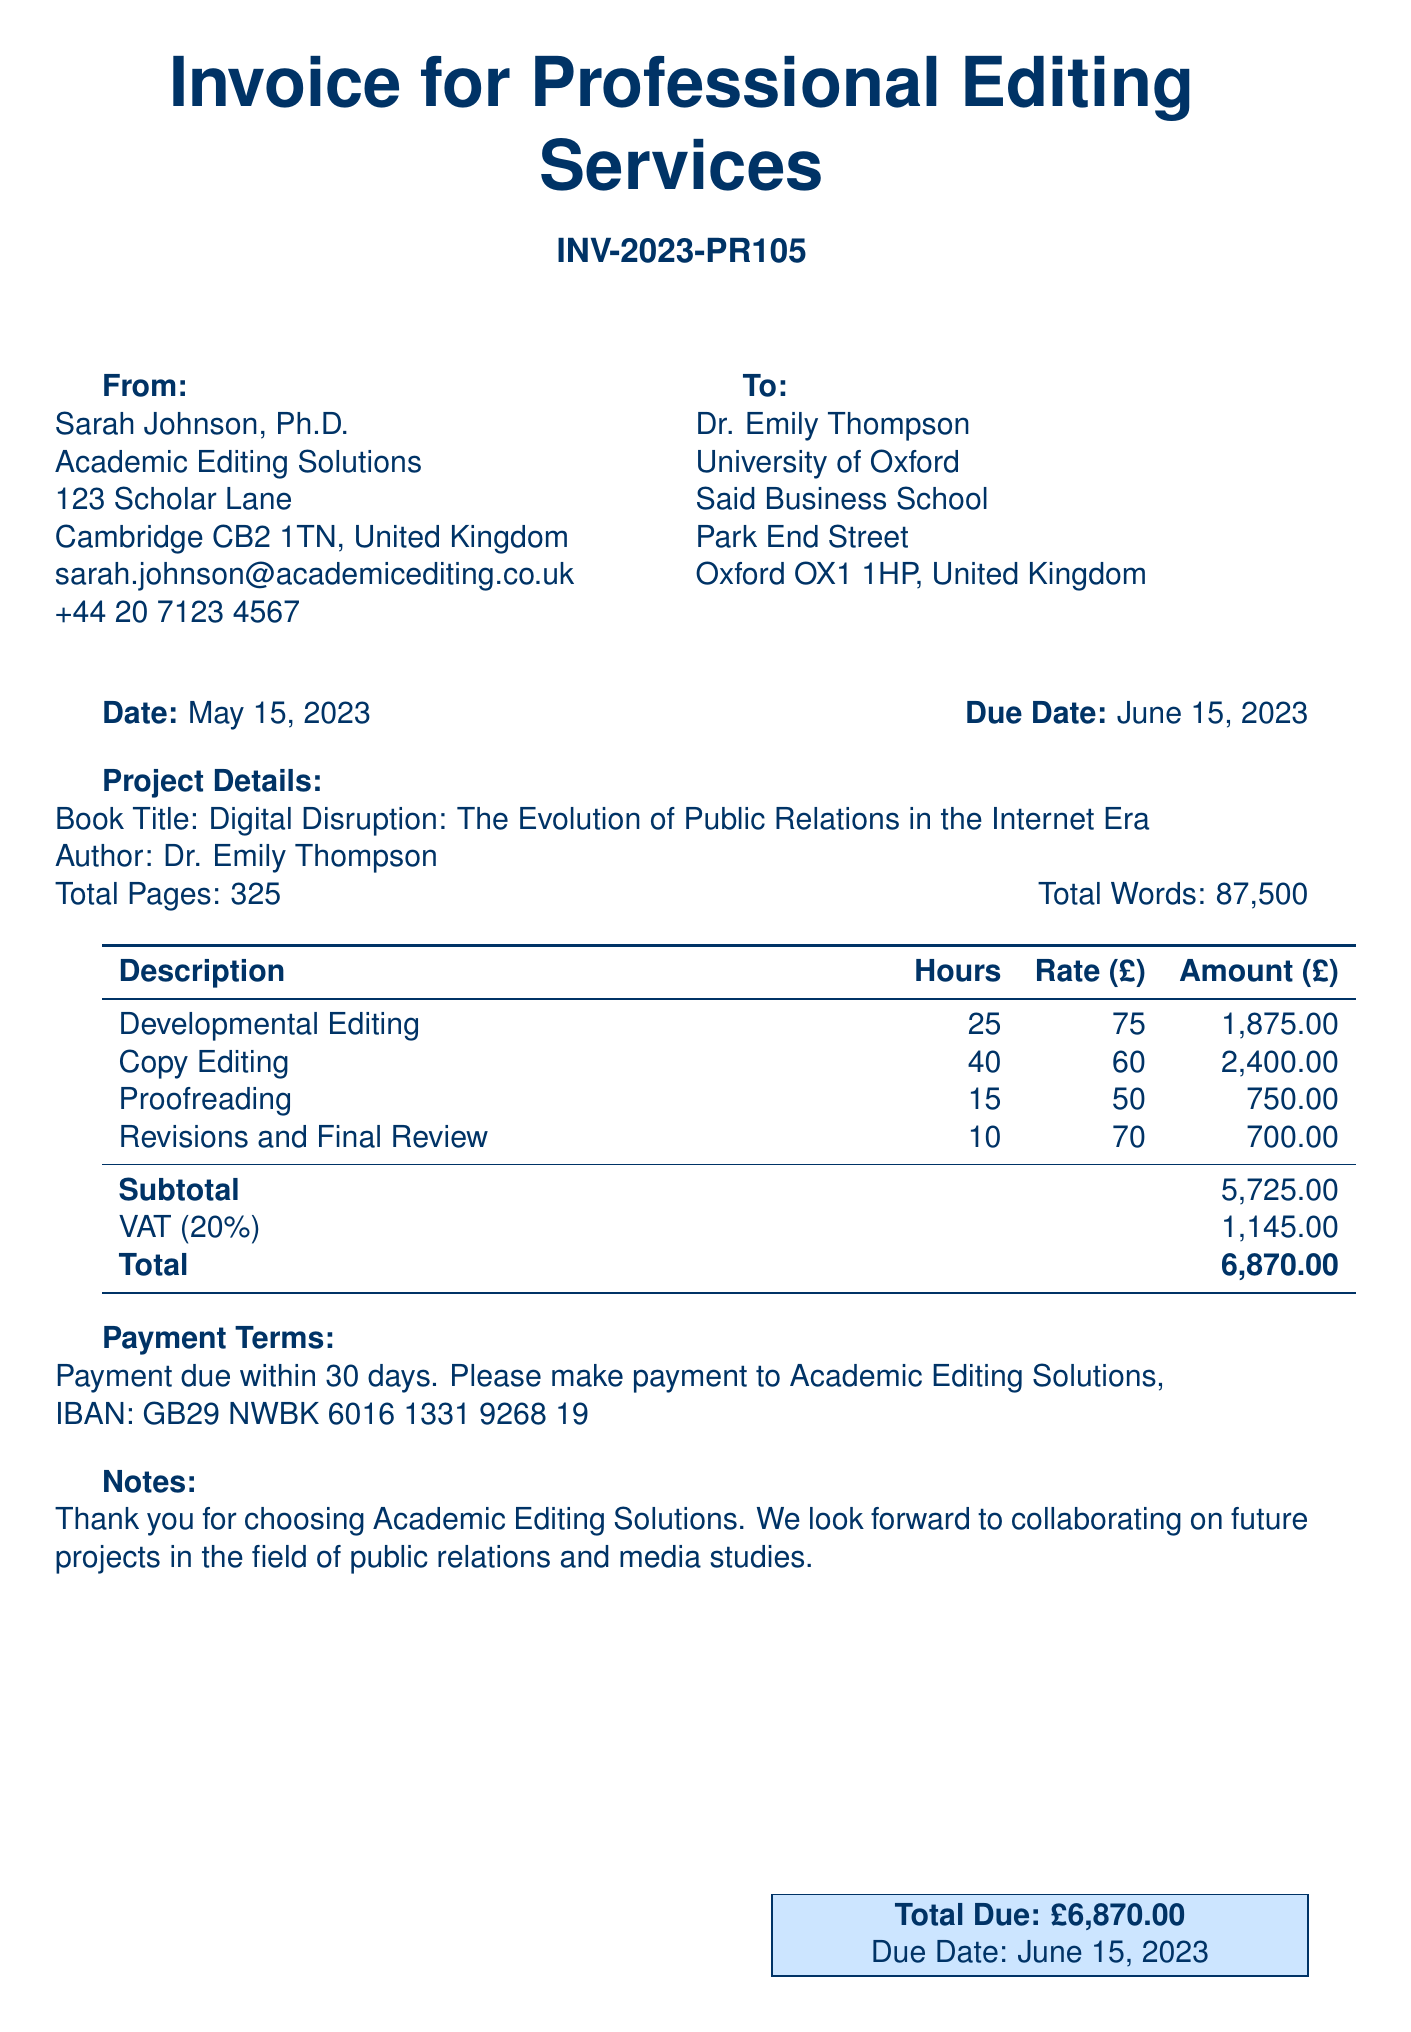What is the invoice number? The invoice number is specified at the top of the document.
Answer: INV-2023-PR105 Who is the editor? The editor's name is provided in the 'From' section of the invoice.
Answer: Sarah Johnson, Ph.D What is the total amount due? The total amount due is calculated at the bottom of the invoice.
Answer: £6,870.00 What is the rate for Copy Editing services? The rate for Copy Editing is listed in the service breakdown.
Answer: £60 How many hours were billed for Proofreading? The number of hours for Proofreading is detailed in the service description.
Answer: 15 What is the VAT percentage applied? The VAT percentage is noted in the invoice.
Answer: 20% What is the due date for payment? The due date for payment is indicated on the invoice.
Answer: June 15, 2023 What is the total number of pages in the book? The total number of pages is mentioned in the project details.
Answer: 325 What is the email address of the editor? The email address is provided in the 'From' section of the invoice.
Answer: sarah.johnson@academicediting.co.uk 